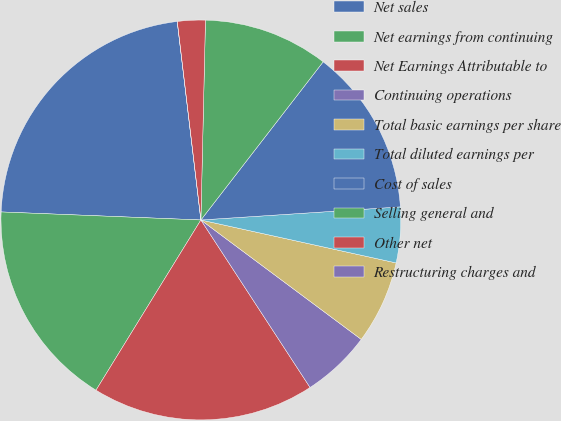Convert chart. <chart><loc_0><loc_0><loc_500><loc_500><pie_chart><fcel>Net sales<fcel>Net earnings from continuing<fcel>Net Earnings Attributable to<fcel>Continuing operations<fcel>Total basic earnings per share<fcel>Total diluted earnings per<fcel>Cost of sales<fcel>Selling general and<fcel>Other net<fcel>Restructuring charges and<nl><fcel>22.47%<fcel>16.85%<fcel>17.98%<fcel>5.62%<fcel>6.74%<fcel>4.49%<fcel>13.48%<fcel>10.11%<fcel>2.25%<fcel>0.0%<nl></chart> 